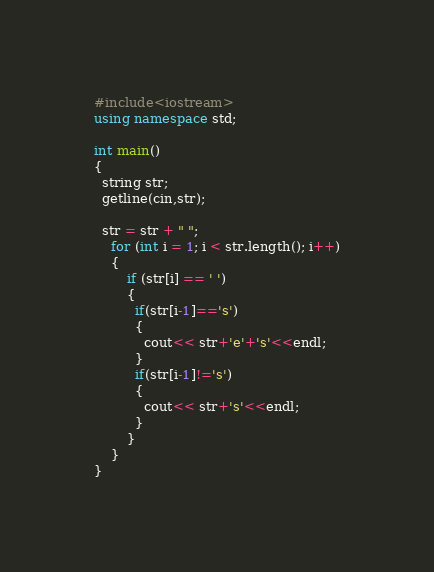Convert code to text. <code><loc_0><loc_0><loc_500><loc_500><_C++_>#include<iostream>
using namespace std;

int main()
{
  string str;
  getline(cin,str);

  str = str + " ";
    for (int i = 1; i < str.length(); i++)
    {
        if (str[i] == ' ')
        {
          if(str[i-1]=='s')
          {
            cout<< str+'e'+'s'<<endl;
          }
          if(str[i-1]!='s')
          {
            cout<< str+'s'<<endl;
          }
        }
    }
}</code> 